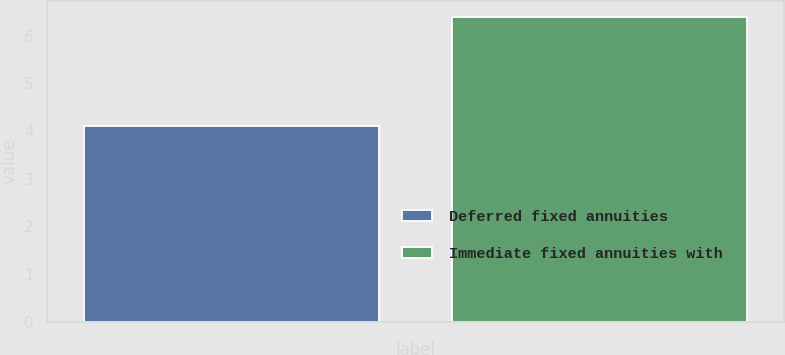Convert chart to OTSL. <chart><loc_0><loc_0><loc_500><loc_500><bar_chart><fcel>Deferred fixed annuities<fcel>Immediate fixed annuities with<nl><fcel>4.1<fcel>6.4<nl></chart> 